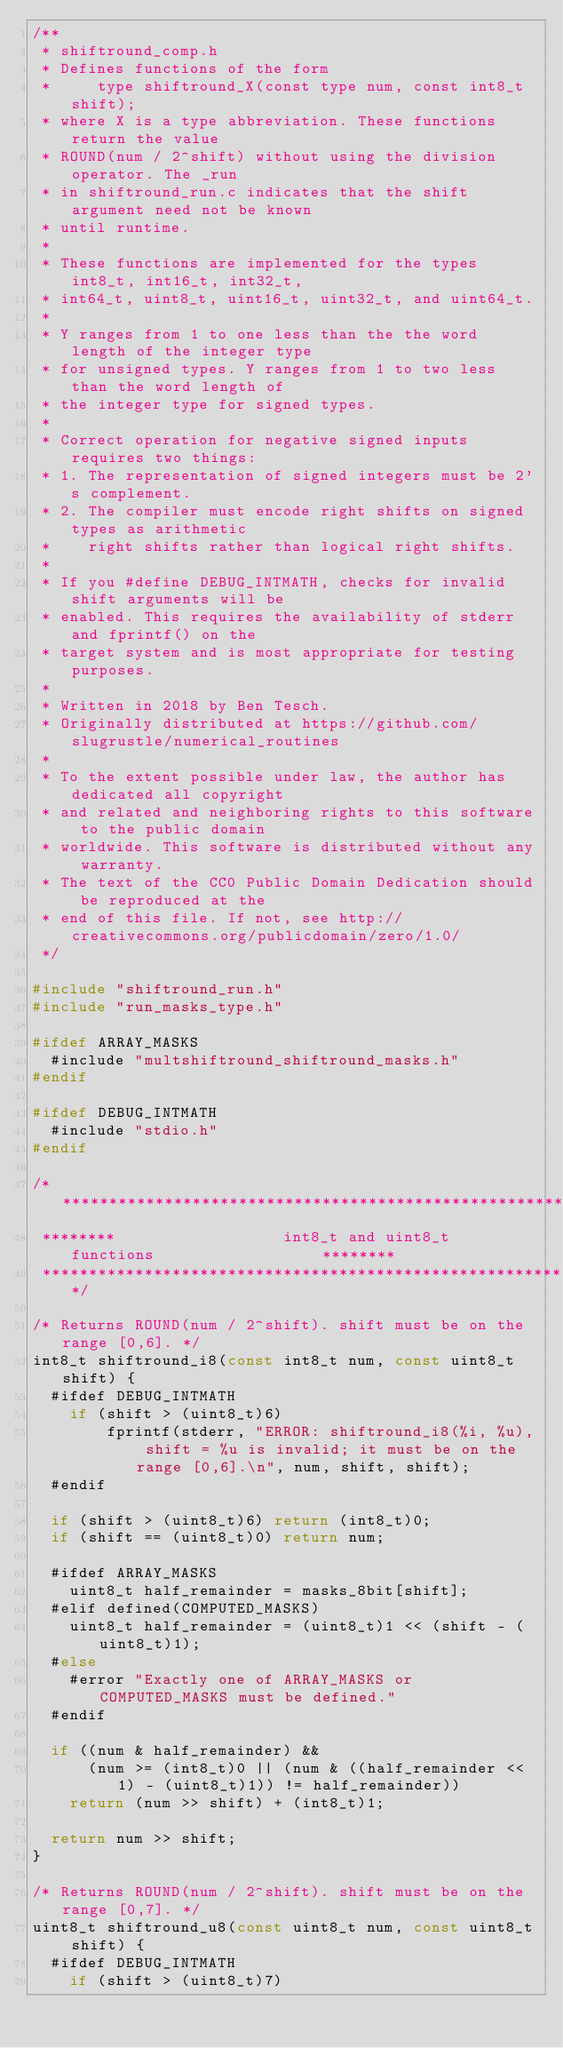Convert code to text. <code><loc_0><loc_0><loc_500><loc_500><_C_>/**
 * shiftround_comp.h
 * Defines functions of the form
 *     type shiftround_X(const type num, const int8_t shift);
 * where X is a type abbreviation. These functions return the value
 * ROUND(num / 2^shift) without using the division operator. The _run
 * in shiftround_run.c indicates that the shift argument need not be known
 * until runtime.
 *
 * These functions are implemented for the types int8_t, int16_t, int32_t,
 * int64_t, uint8_t, uint16_t, uint32_t, and uint64_t.
 *
 * Y ranges from 1 to one less than the the word length of the integer type
 * for unsigned types. Y ranges from 1 to two less than the word length of
 * the integer type for signed types.
 *
 * Correct operation for negative signed inputs requires two things:
 * 1. The representation of signed integers must be 2's complement.
 * 2. The compiler must encode right shifts on signed types as arithmetic
 *    right shifts rather than logical right shifts.
 * 
 * If you #define DEBUG_INTMATH, checks for invalid shift arguments will be
 * enabled. This requires the availability of stderr and fprintf() on the
 * target system and is most appropriate for testing purposes.
 *
 * Written in 2018 by Ben Tesch.
 * Originally distributed at https://github.com/slugrustle/numerical_routines
 *
 * To the extent possible under law, the author has dedicated all copyright
 * and related and neighboring rights to this software to the public domain
 * worldwide. This software is distributed without any warranty.
 * The text of the CC0 Public Domain Dedication should be reproduced at the
 * end of this file. If not, see http://creativecommons.org/publicdomain/zero/1.0/
 */

#include "shiftround_run.h"
#include "run_masks_type.h"

#ifdef ARRAY_MASKS
  #include "multshiftround_shiftround_masks.h"
#endif

#ifdef DEBUG_INTMATH
  #include "stdio.h"
#endif

/********************************************************************************
 ********                  int8_t and uint8_t functions                  ********
 ********************************************************************************/

/* Returns ROUND(num / 2^shift). shift must be on the range [0,6]. */
int8_t shiftround_i8(const int8_t num, const uint8_t shift) {
  #ifdef DEBUG_INTMATH
    if (shift > (uint8_t)6)
	    fprintf(stderr, "ERROR: shiftround_i8(%i, %u), shift = %u is invalid; it must be on the range [0,6].\n", num, shift, shift);
  #endif

  if (shift > (uint8_t)6) return (int8_t)0;
  if (shift == (uint8_t)0) return num;

  #ifdef ARRAY_MASKS
    uint8_t half_remainder = masks_8bit[shift];
  #elif defined(COMPUTED_MASKS)
    uint8_t half_remainder = (uint8_t)1 << (shift - (uint8_t)1);
  #else
    #error "Exactly one of ARRAY_MASKS or COMPUTED_MASKS must be defined."
  #endif

  if ((num & half_remainder) &&
      (num >= (int8_t)0 || (num & ((half_remainder << 1) - (uint8_t)1)) != half_remainder))
    return (num >> shift) + (int8_t)1;

  return num >> shift;
}

/* Returns ROUND(num / 2^shift). shift must be on the range [0,7]. */
uint8_t shiftround_u8(const uint8_t num, const uint8_t shift) {
  #ifdef DEBUG_INTMATH
    if (shift > (uint8_t)7)</code> 